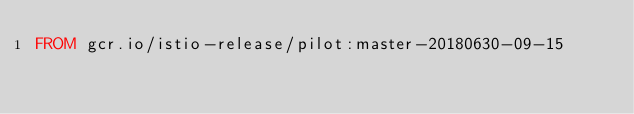<code> <loc_0><loc_0><loc_500><loc_500><_Dockerfile_>FROM gcr.io/istio-release/pilot:master-20180630-09-15
</code> 